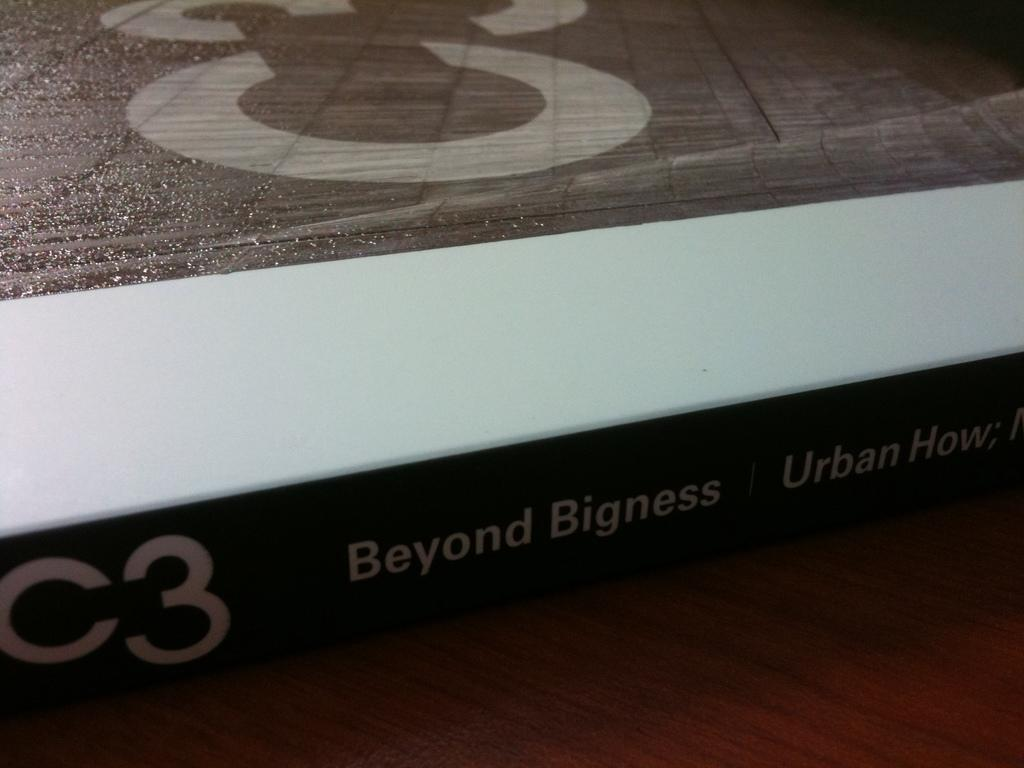Provide a one-sentence caption for the provided image. Beyond Bigness is about urban environments and is coded C3. 